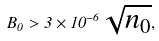<formula> <loc_0><loc_0><loc_500><loc_500>B _ { 0 } > 3 \times 1 0 ^ { - 6 } \sqrt { n _ { 0 } } ,</formula> 